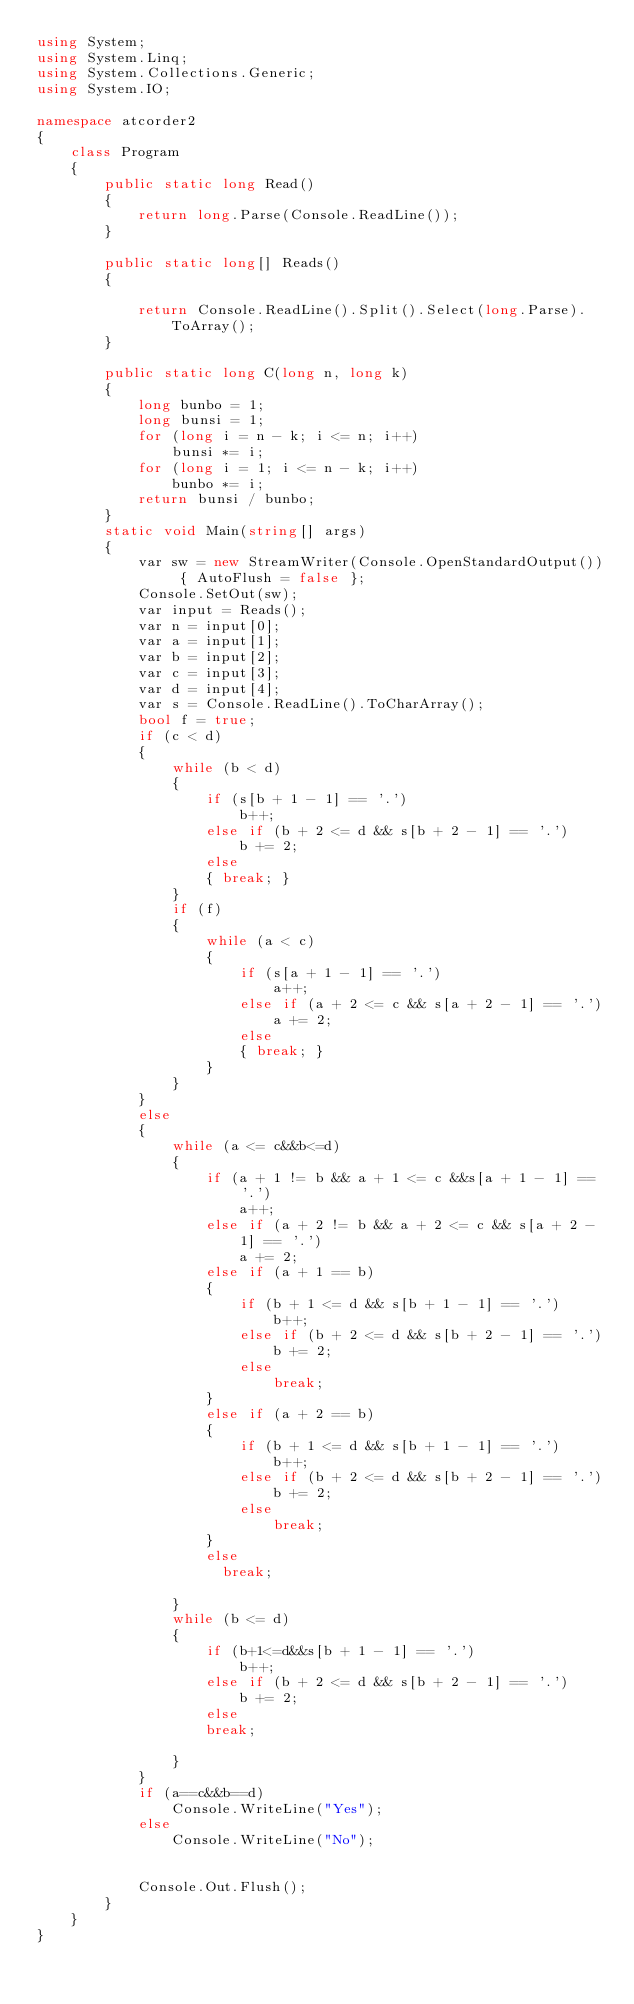<code> <loc_0><loc_0><loc_500><loc_500><_C#_>using System;
using System.Linq;
using System.Collections.Generic;
using System.IO;

namespace atcorder2
{
    class Program
    {
        public static long Read()
        {
            return long.Parse(Console.ReadLine());
        }

        public static long[] Reads()
        {

            return Console.ReadLine().Split().Select(long.Parse).ToArray();
        }

        public static long C(long n, long k)
        {
            long bunbo = 1;
            long bunsi = 1;
            for (long i = n - k; i <= n; i++)
                bunsi *= i;
            for (long i = 1; i <= n - k; i++)
                bunbo *= i;
            return bunsi / bunbo;
        }
        static void Main(string[] args)
        {
            var sw = new StreamWriter(Console.OpenStandardOutput()) { AutoFlush = false };
            Console.SetOut(sw);
            var input = Reads();
            var n = input[0];
            var a = input[1];
            var b = input[2];
            var c = input[3];
            var d = input[4];
            var s = Console.ReadLine().ToCharArray();
            bool f = true;
            if (c < d)
            {
                while (b < d)
                {
                    if (s[b + 1 - 1] == '.')
                        b++;
                    else if (b + 2 <= d && s[b + 2 - 1] == '.')
                        b += 2;
                    else
                    { break; }
                }
                if (f)
                {
                    while (a < c)
                    {
                        if (s[a + 1 - 1] == '.')
                            a++;
                        else if (a + 2 <= c && s[a + 2 - 1] == '.')
                            a += 2;
                        else
                        { break; }
                    }
                }
            }
            else
            {
                while (a <= c&&b<=d)
                {
                    if (a + 1 != b && a + 1 <= c &&s[a + 1 - 1] == '.')
                        a++;
                    else if (a + 2 != b && a + 2 <= c && s[a + 2 - 1] == '.')
                        a += 2;
                    else if (a + 1 == b)
                    {
                        if (b + 1 <= d && s[b + 1 - 1] == '.')
                            b++;
                        else if (b + 2 <= d && s[b + 2 - 1] == '.')
                            b += 2;
                        else
                            break;
                    }
                    else if (a + 2 == b)
                    {
                        if (b + 1 <= d && s[b + 1 - 1] == '.')
                            b++;
                        else if (b + 2 <= d && s[b + 2 - 1] == '.')
                            b += 2;
                        else
                            break;
                    }
                    else 
                      break; 
                    
                }
                while (b <= d)
                {
                    if (b+1<=d&&s[b + 1 - 1] == '.')
                        b++;
                    else if (b + 2 <= d && s[b + 2 - 1] == '.')
                        b += 2;
                    else
                    break; 
               
                }
            }
            if (a==c&&b==d)
                Console.WriteLine("Yes");
            else
                Console.WriteLine("No");


            Console.Out.Flush();
        }
    }
}</code> 